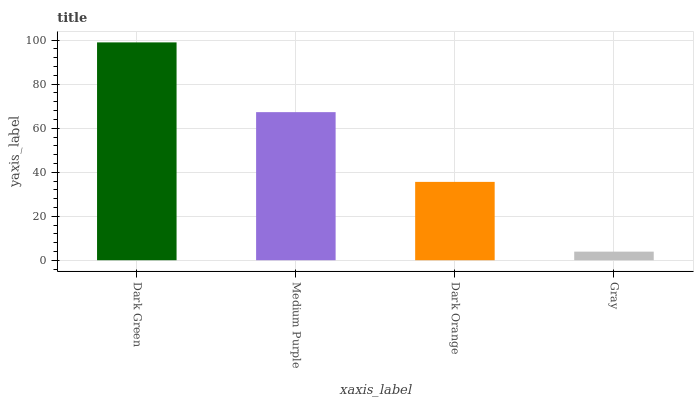Is Gray the minimum?
Answer yes or no. Yes. Is Dark Green the maximum?
Answer yes or no. Yes. Is Medium Purple the minimum?
Answer yes or no. No. Is Medium Purple the maximum?
Answer yes or no. No. Is Dark Green greater than Medium Purple?
Answer yes or no. Yes. Is Medium Purple less than Dark Green?
Answer yes or no. Yes. Is Medium Purple greater than Dark Green?
Answer yes or no. No. Is Dark Green less than Medium Purple?
Answer yes or no. No. Is Medium Purple the high median?
Answer yes or no. Yes. Is Dark Orange the low median?
Answer yes or no. Yes. Is Gray the high median?
Answer yes or no. No. Is Dark Green the low median?
Answer yes or no. No. 